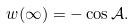Convert formula to latex. <formula><loc_0><loc_0><loc_500><loc_500>w ( \infty ) = - \cos \mathcal { A } .</formula> 